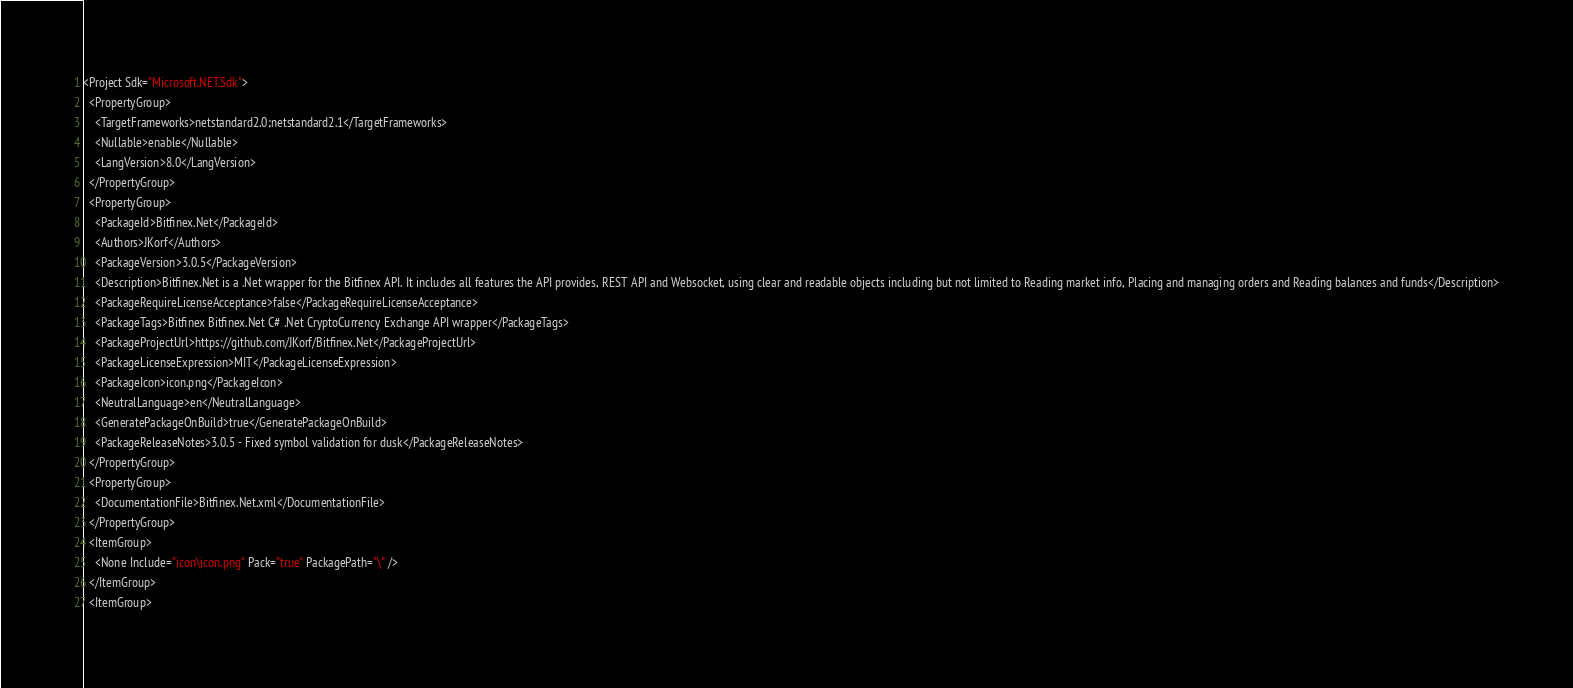<code> <loc_0><loc_0><loc_500><loc_500><_XML_><Project Sdk="Microsoft.NET.Sdk">
  <PropertyGroup>
    <TargetFrameworks>netstandard2.0;netstandard2.1</TargetFrameworks>
    <Nullable>enable</Nullable>
    <LangVersion>8.0</LangVersion>
  </PropertyGroup>
  <PropertyGroup>
    <PackageId>Bitfinex.Net</PackageId>
    <Authors>JKorf</Authors>
    <PackageVersion>3.0.5</PackageVersion>
    <Description>Bitfinex.Net is a .Net wrapper for the Bitfinex API. It includes all features the API provides, REST API and Websocket, using clear and readable objects including but not limited to Reading market info, Placing and managing orders and Reading balances and funds</Description>
    <PackageRequireLicenseAcceptance>false</PackageRequireLicenseAcceptance>
    <PackageTags>Bitfinex Bitfinex.Net C# .Net CryptoCurrency Exchange API wrapper</PackageTags>
    <PackageProjectUrl>https://github.com/JKorf/Bitfinex.Net</PackageProjectUrl>
    <PackageLicenseExpression>MIT</PackageLicenseExpression>
    <PackageIcon>icon.png</PackageIcon>
    <NeutralLanguage>en</NeutralLanguage>
    <GeneratePackageOnBuild>true</GeneratePackageOnBuild>
    <PackageReleaseNotes>3.0.5 - Fixed symbol validation for dusk</PackageReleaseNotes>
  </PropertyGroup>
  <PropertyGroup>
    <DocumentationFile>Bitfinex.Net.xml</DocumentationFile>
  </PropertyGroup>
  <ItemGroup>
    <None Include="icon\icon.png" Pack="true" PackagePath="\" />
  </ItemGroup>
  <ItemGroup></code> 